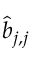<formula> <loc_0><loc_0><loc_500><loc_500>\hat { b } _ { j , j }</formula> 